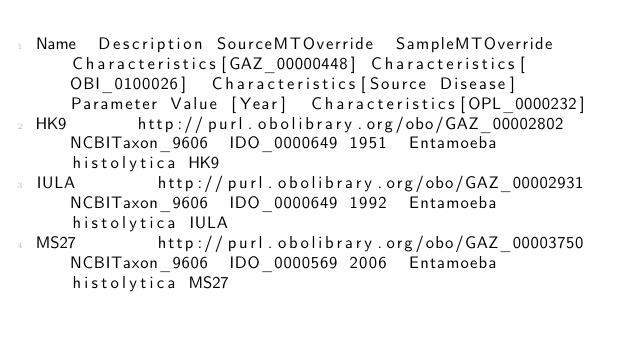<code> <loc_0><loc_0><loc_500><loc_500><_SQL_>Name	Description	SourceMTOverride	SampleMTOverride	Characteristics[GAZ_00000448]	Characteristics[OBI_0100026]	Characteristics[Source Disease]	Parameter Value [Year]	Characteristics[OPL_0000232]
HK9				http://purl.obolibrary.org/obo/GAZ_00002802	NCBITaxon_9606	IDO_0000649	1951	Entamoeba histolytica HK9
IULA				http://purl.obolibrary.org/obo/GAZ_00002931	NCBITaxon_9606	IDO_0000649	1992	Entamoeba histolytica IULA
MS27				http://purl.obolibrary.org/obo/GAZ_00003750	NCBITaxon_9606	IDO_0000569	2006	Entamoeba histolytica MS27</code> 